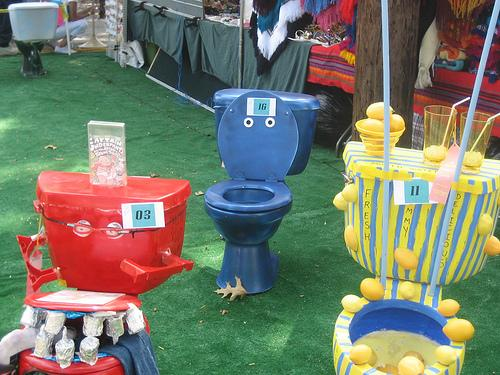What is the primary color of the toilet in the image and what designs does it have? The primary color of the toilet is blue and it has lemon designs. Describe the main object's color and its distinctive design elements present in the image. The main object is a blue toilet with lemon designs situated on various parts of the toilet. Considering the given information, rate the overall image quality on a scale from 1 to 10, with 1 being the worst and 10 being the best. Based on the object descriptions and details, I would rate the overall image quality as a 7 due to its variety of elements and unique features. Enumerate the number of lemons on the toilet found in the image. There are 20 lemons on the toilet in various positions and sizes. How many times are the words "floor" and "line" mentioned in the image captions? Floor is mentioned 2 times while line is mentioned 2 times as well, making it 4 times combined. Explain whether there's any complex reasoning portrayed in the image by analyzing the interaction of objects. The image doesn't necessarily portray complex reasoning but showcases a creative and unconventional composition through the interaction of a blue toilet and lemon designs. Predict the interaction between the main object and the elements described in the given captions. The lemons decorating the main object, the blue toilet, interact with the toilet's design and create a playful and unique appearance. Analyze the different elements of the image to determine the overall sentiment it conveys. The image conveys a lighthearted and whimsical sentiment due to the presence of a blue toilet with lemon designs. Describe any significant events or activities in the image. No significant events or activities detected. Identify the possible placement of an item titled 'lemon on a toilet.' Positions include: near the tank, on the seat, and around the base. What is the color of the toilet in the image? Blue Find and describe the object located at approximately (390, 237). Part of a board Is there a towel in the image? If so, provide a brief description. Yes, there is a part of a towel visible. Is the toilet in the image pink in color? The given information shows that the toilet's color is blue, so by asking if it is pink, it becomes a misleading question. Explain what's visible on the side of a tank in the image. There's no clear information about what's visible on the side of a tank. What type of fruit is on the toilet? Lemon Is there an edge of a river at X:330 Y:257 Width:10 Height:10 in the image? The given information for those coordinates and dimensions is for an edge of a field, not a river, making this question misleading. Is there a part of a roof in the image that has X:297 Y:308 Width:44 Height:44? The given information for those coordinates and dimensions is for a part of a floor, not a roof, so the question is misleading. Based on the image, provide a brief understanding of the diagram. The image shows the positions and captions of various objects, including a blue toilet with lemon designs, a towel, a tank, and a floor. Recognize and describe any activities implied in the image. No specific activities are implied by the image. Write a creative caption for the toilet with lemon designs. "When life hands you lemons, decorate your toilet." Does the image show a lemon on a toilet with X:486 Y:235 Width:30 Height:30? The given information indicates that the lemon on a toilet has X:486 Y:235 Width:12 Height:12, not Width:30 Height:30, so the question is misleading. Explain what can be found at the edge of the field in the image. There is no clear information about what's at the edge of the field. Does the image show a part of a wall with X:390 Y:237 Width:12 Height:12? The given information for those coordinates and dimensions is for a part of a board, not a wall, which makes the question misleading. Write a brief description of an object found at approximately (330, 257). Edge of a field As you observe the image, what types of materials or objects do you detect as part of a line? It is unclear which objects are part of a line. Are there any apples on the toilet in the image? The information mentions lemons on the toilet, but not apples, so asking about apples is misleading. Choose the correct statement: The toilet has flower designs, The toilet has lemon designs, The toilet has no designs. The toilet has lemon designs Identify an object present at the left-top corner with coordinates close to (297, 308). Part of a floor What is the shape of the object found at the left-top corner with coordinates close to (86, 211)? Part of a tank Describe the appearance of the toilet. The toilet is blue and has lemon designs on it. 